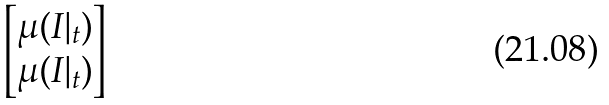Convert formula to latex. <formula><loc_0><loc_0><loc_500><loc_500>\begin{bmatrix} \mu ( I | _ { t } ) \\ \mu ( I | _ { t } ) \end{bmatrix}</formula> 